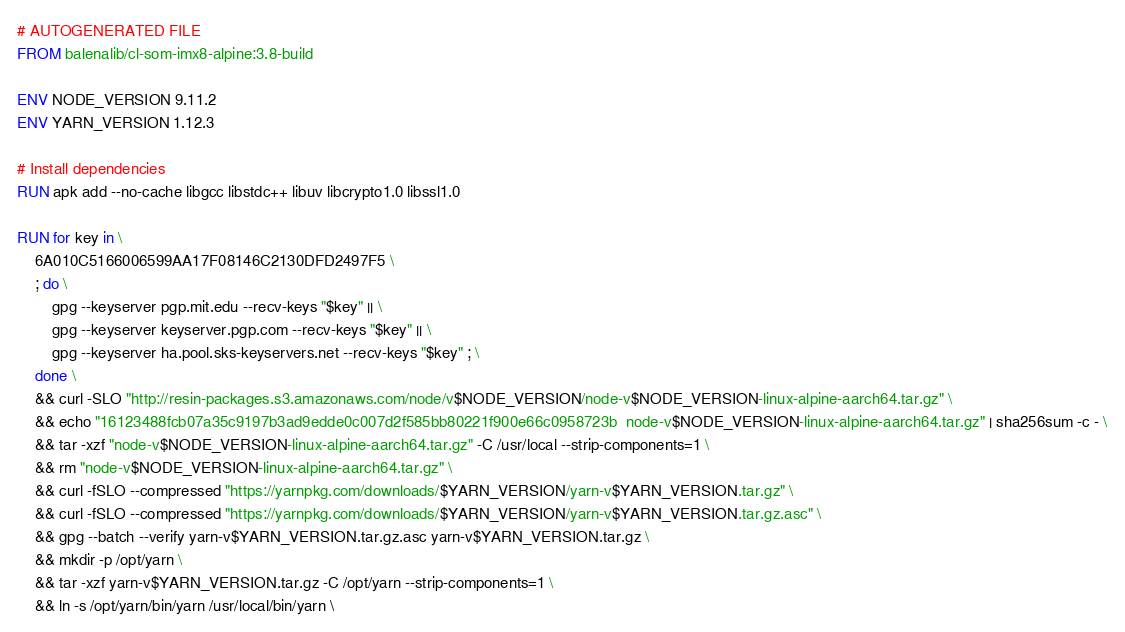<code> <loc_0><loc_0><loc_500><loc_500><_Dockerfile_># AUTOGENERATED FILE
FROM balenalib/cl-som-imx8-alpine:3.8-build

ENV NODE_VERSION 9.11.2
ENV YARN_VERSION 1.12.3

# Install dependencies
RUN apk add --no-cache libgcc libstdc++ libuv libcrypto1.0 libssl1.0

RUN for key in \
	6A010C5166006599AA17F08146C2130DFD2497F5 \
	; do \
		gpg --keyserver pgp.mit.edu --recv-keys "$key" || \
		gpg --keyserver keyserver.pgp.com --recv-keys "$key" || \
		gpg --keyserver ha.pool.sks-keyservers.net --recv-keys "$key" ; \
	done \
	&& curl -SLO "http://resin-packages.s3.amazonaws.com/node/v$NODE_VERSION/node-v$NODE_VERSION-linux-alpine-aarch64.tar.gz" \
	&& echo "16123488fcb07a35c9197b3ad9edde0c007d2f585bb80221f900e66c0958723b  node-v$NODE_VERSION-linux-alpine-aarch64.tar.gz" | sha256sum -c - \
	&& tar -xzf "node-v$NODE_VERSION-linux-alpine-aarch64.tar.gz" -C /usr/local --strip-components=1 \
	&& rm "node-v$NODE_VERSION-linux-alpine-aarch64.tar.gz" \
	&& curl -fSLO --compressed "https://yarnpkg.com/downloads/$YARN_VERSION/yarn-v$YARN_VERSION.tar.gz" \
	&& curl -fSLO --compressed "https://yarnpkg.com/downloads/$YARN_VERSION/yarn-v$YARN_VERSION.tar.gz.asc" \
	&& gpg --batch --verify yarn-v$YARN_VERSION.tar.gz.asc yarn-v$YARN_VERSION.tar.gz \
	&& mkdir -p /opt/yarn \
	&& tar -xzf yarn-v$YARN_VERSION.tar.gz -C /opt/yarn --strip-components=1 \
	&& ln -s /opt/yarn/bin/yarn /usr/local/bin/yarn \</code> 